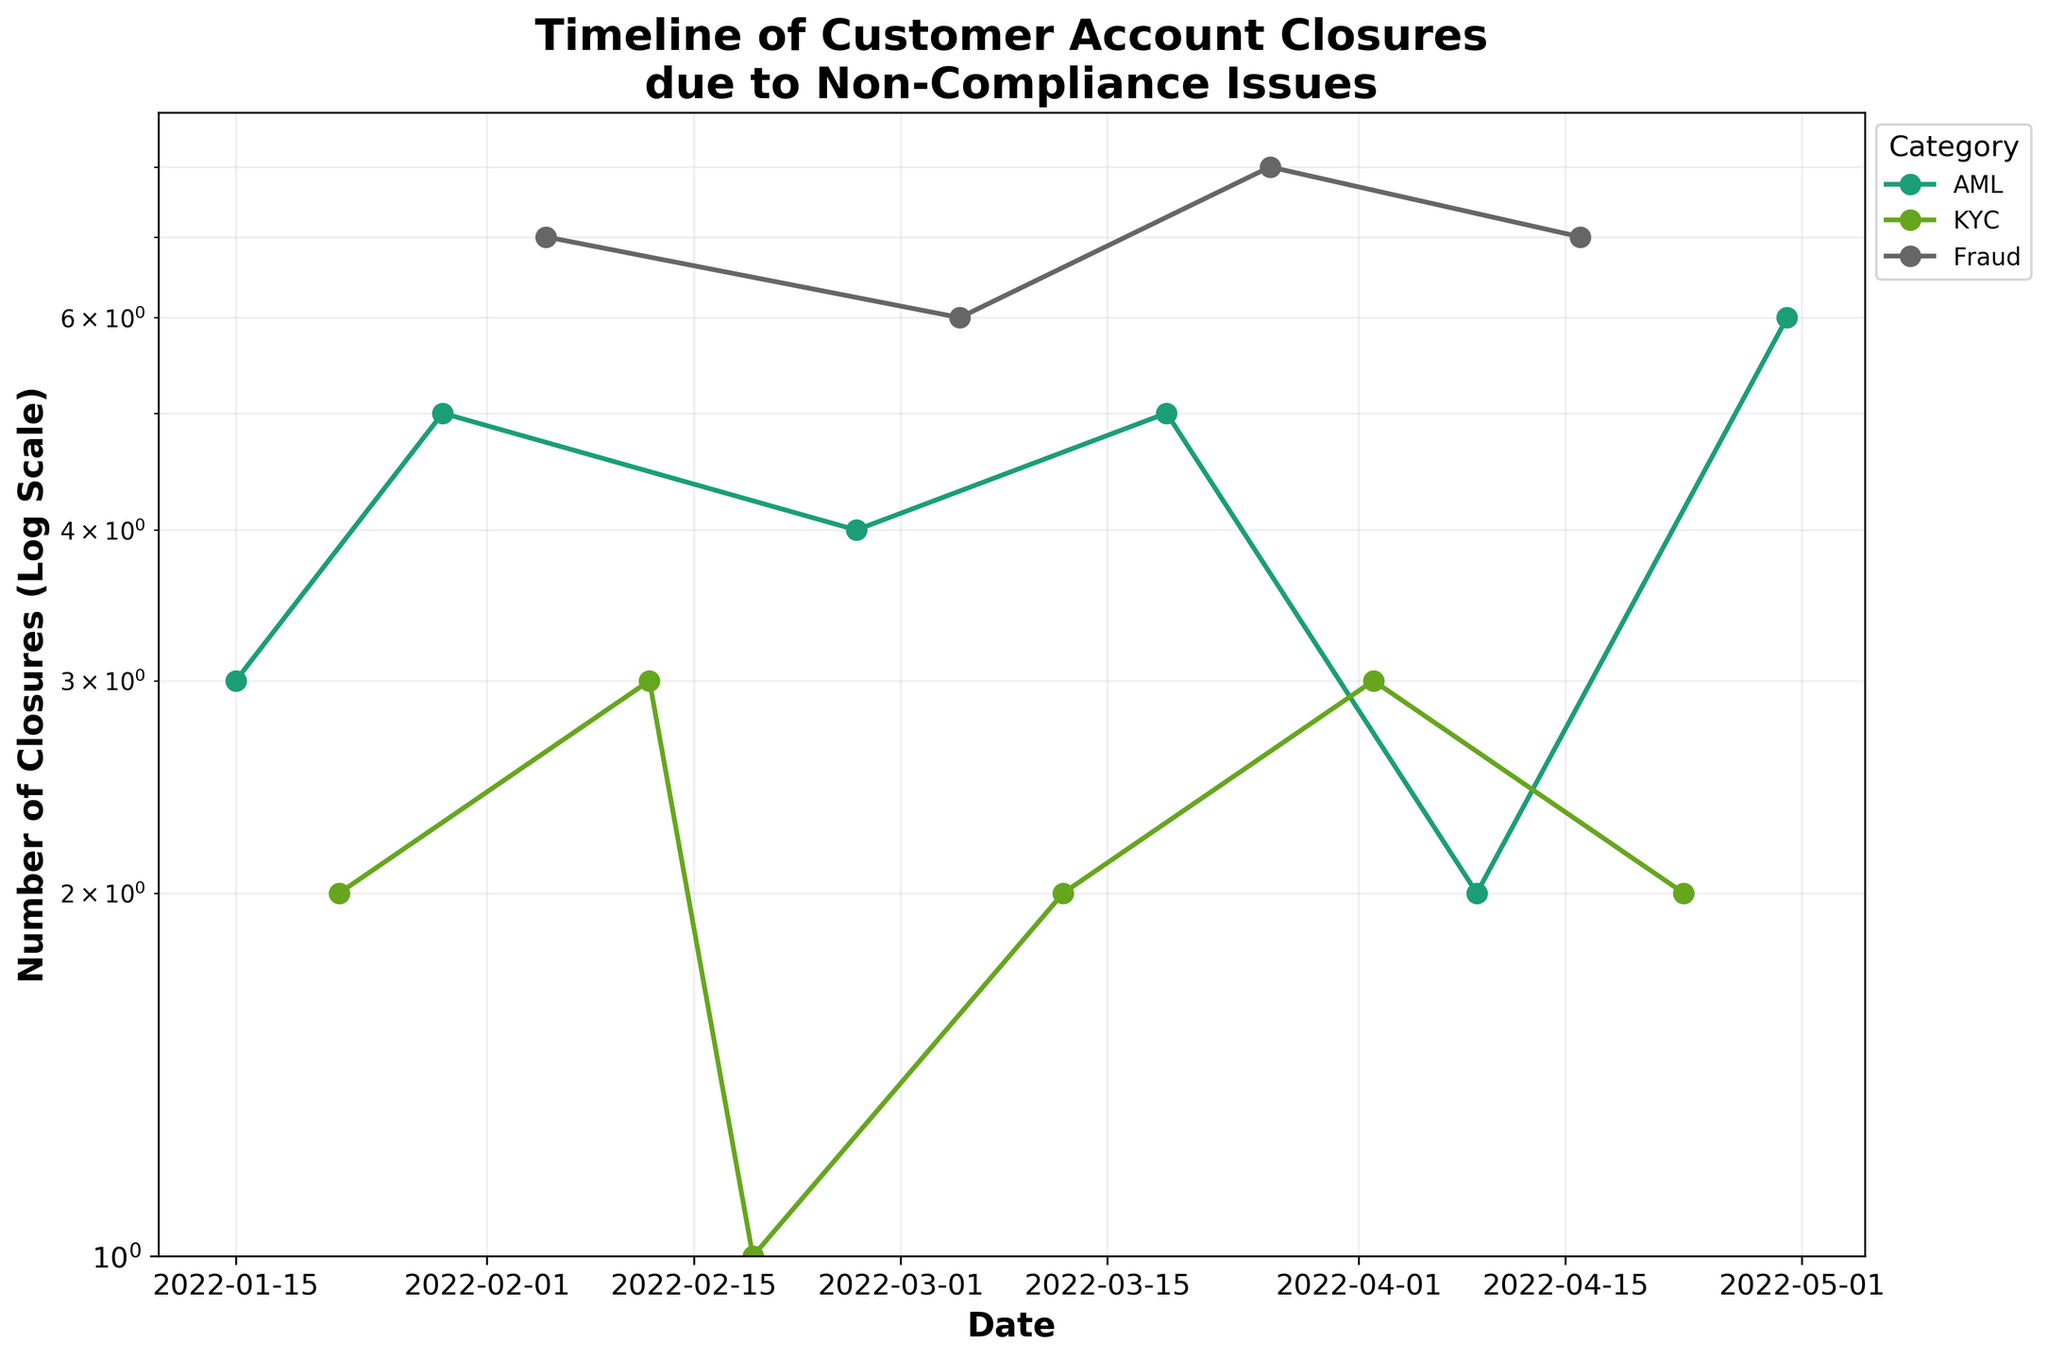What's the title of the plot? The title is placed at the top of the figure and provides a summary of what the plot represents. It reads: "Timeline of Customer Account Closures due to Non-Compliance Issues".
Answer: Timeline of Customer Account Closures due to Non-Compliance Issues How many categories of non-compliance issues are there? By examining the legend on the right side of the plot, we can see the different categories plotted with distinct colors.
Answer: 3 What category had the highest number of closures on February 5, 2022? By locating the date on the x-axis (February 5, 2022) and looking at the corresponding points, we see that 'Fraud' had the highest number of closures on this date, marked with a peak on the plot.
Answer: Fraud What is the range of dates covered in this plot? By examining the x-axis, which represents the timeline from the first to the last plotted date, we can identify the date range. The plot starts on January 15, 2022, and ends on April 30, 2022.
Answer: January 15, 2022 to April 30, 2022 What is the minimum number of closures represented in the plot? Examining the y-axis with a log scale, the minimum value depicted just above 1 is 1 closure. This can be confirmed by locating the smallest points in the plot.
Answer: 1 Which category had the most consistent number of closures? We look for categories with points forming a nearly horizontal line or minimal fluctuation. The 'KYC' category shows less variation compared to 'AML' and 'Fraud'.
Answer: KYC On which date did 'AML' see the highest number of closures? By focusing on the 'AML' line and looking for the highest point along this line, we find it on April 30, 2022.
Answer: April 30, 2022 Which date had the highest overall number of closures and which category contributed to it? By scanning vertically across all dates, the highest peak by any category happens on March 26, 2022, with 'Fraud' showing the highest count.
Answer: March 26, 2022, Fraud How does the trend of 'Fraud' closures from January 15, 2022, to April 30, 2022, compare with 'KYC'? We need to compare the overall pattern of the 'Fraud' line to that of 'KYC'. 'Fraud' shows more peaks and fluctuations, while 'KYC' is relatively stable with lower values.
Answer: 'Fraud' fluctuates more with higher peaks; 'KYC' is more stable with lower values What was the number of 'KYC' closures on February 12, 2022? By locating February 12, 2022, on the x-axis and tracing the curve for 'KYC', we find the corresponding point. The 'KYC' closure count for that date is 3.
Answer: 3 